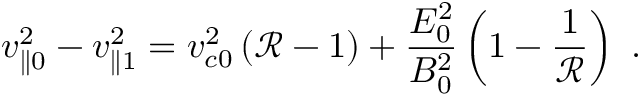<formula> <loc_0><loc_0><loc_500><loc_500>v _ { \| 0 } ^ { 2 } - v _ { \| 1 } ^ { 2 } = v _ { c 0 } ^ { 2 } \left ( \mathcal { R } - 1 \right ) + \frac { E _ { 0 } ^ { 2 } } { B _ { 0 } ^ { 2 } } \left ( 1 - \frac { 1 } { \mathcal { R } } \right ) .</formula> 